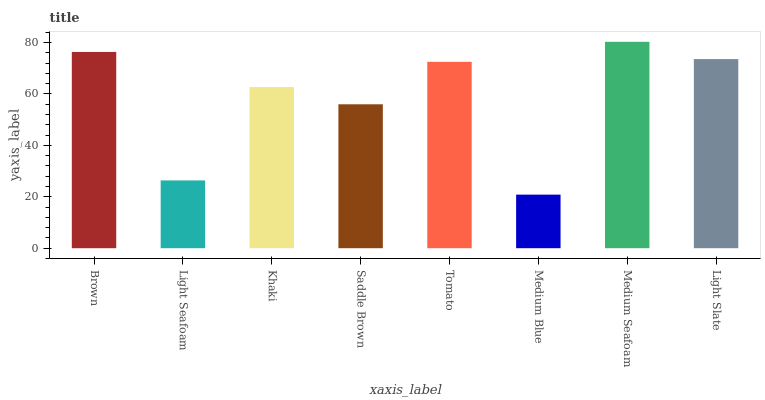Is Medium Blue the minimum?
Answer yes or no. Yes. Is Medium Seafoam the maximum?
Answer yes or no. Yes. Is Light Seafoam the minimum?
Answer yes or no. No. Is Light Seafoam the maximum?
Answer yes or no. No. Is Brown greater than Light Seafoam?
Answer yes or no. Yes. Is Light Seafoam less than Brown?
Answer yes or no. Yes. Is Light Seafoam greater than Brown?
Answer yes or no. No. Is Brown less than Light Seafoam?
Answer yes or no. No. Is Tomato the high median?
Answer yes or no. Yes. Is Khaki the low median?
Answer yes or no. Yes. Is Light Slate the high median?
Answer yes or no. No. Is Brown the low median?
Answer yes or no. No. 